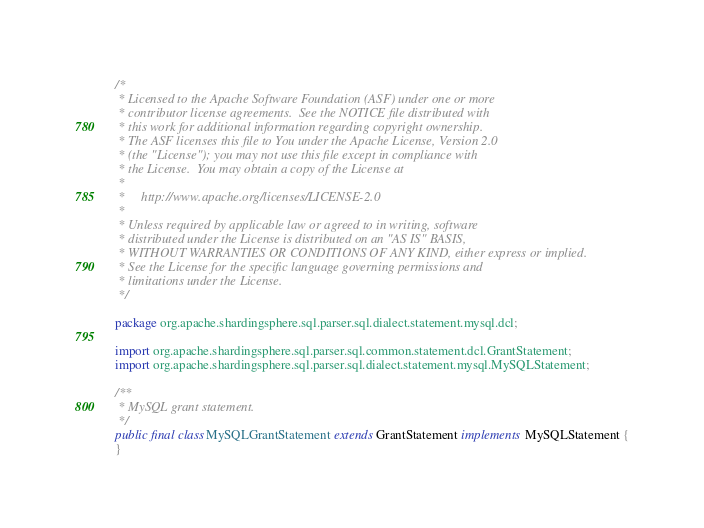Convert code to text. <code><loc_0><loc_0><loc_500><loc_500><_Java_>/*
 * Licensed to the Apache Software Foundation (ASF) under one or more
 * contributor license agreements.  See the NOTICE file distributed with
 * this work for additional information regarding copyright ownership.
 * The ASF licenses this file to You under the Apache License, Version 2.0
 * (the "License"); you may not use this file except in compliance with
 * the License.  You may obtain a copy of the License at
 *
 *     http://www.apache.org/licenses/LICENSE-2.0
 *
 * Unless required by applicable law or agreed to in writing, software
 * distributed under the License is distributed on an "AS IS" BASIS,
 * WITHOUT WARRANTIES OR CONDITIONS OF ANY KIND, either express or implied.
 * See the License for the specific language governing permissions and
 * limitations under the License.
 */

package org.apache.shardingsphere.sql.parser.sql.dialect.statement.mysql.dcl;

import org.apache.shardingsphere.sql.parser.sql.common.statement.dcl.GrantStatement;
import org.apache.shardingsphere.sql.parser.sql.dialect.statement.mysql.MySQLStatement;

/**
 * MySQL grant statement.
 */
public final class MySQLGrantStatement extends GrantStatement implements MySQLStatement {
}
</code> 